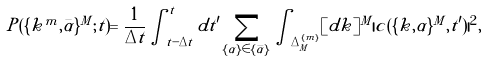<formula> <loc_0><loc_0><loc_500><loc_500>P ( \{ { k ^ { m } } , \bar { \alpha } \} ^ { M } ; t ) = \frac { 1 } { \Delta t } \int _ { t - \Delta t } ^ { t } d t ^ { \prime } \sum _ { \{ \alpha \} \in \{ { \bar { \alpha } } \} } \int _ { \Delta ^ { \{ m \} } _ { M } } [ d { k } ] ^ { M } | c ( \{ { k } , { \alpha } \} ^ { M } , t ^ { \prime } ) | ^ { 2 } ,</formula> 